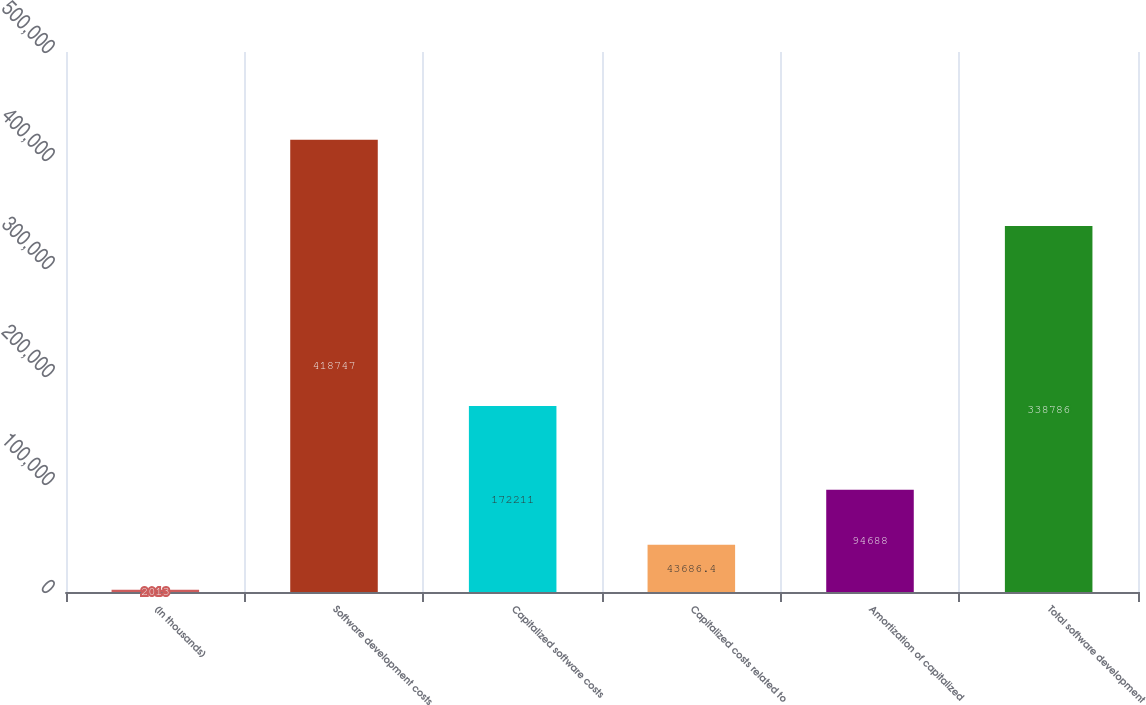Convert chart to OTSL. <chart><loc_0><loc_0><loc_500><loc_500><bar_chart><fcel>(In thousands)<fcel>Software development costs<fcel>Capitalized software costs<fcel>Capitalized costs related to<fcel>Amortization of capitalized<fcel>Total software development<nl><fcel>2013<fcel>418747<fcel>172211<fcel>43686.4<fcel>94688<fcel>338786<nl></chart> 